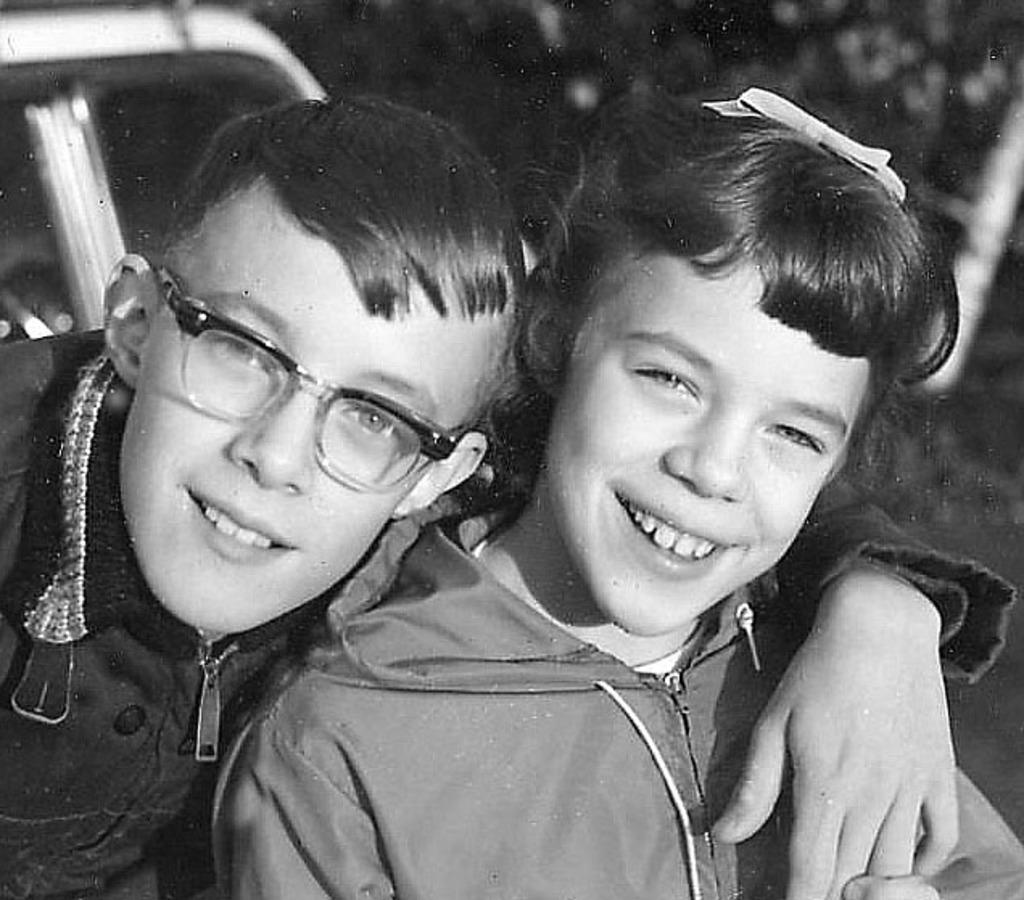How many kids are present in the image? There are two kids in the image. What is the facial expression of the kids? The kids are smiling. What can be seen in the background of the image? There is a vehicle in the background of the image. How many goldfish are swimming in the image? There are no goldfish present in the image; it features two kids and a vehicle in the background. What type of machine is being used by the kids in the image? There is no machine being used by the kids in the image; they are simply smiling. 